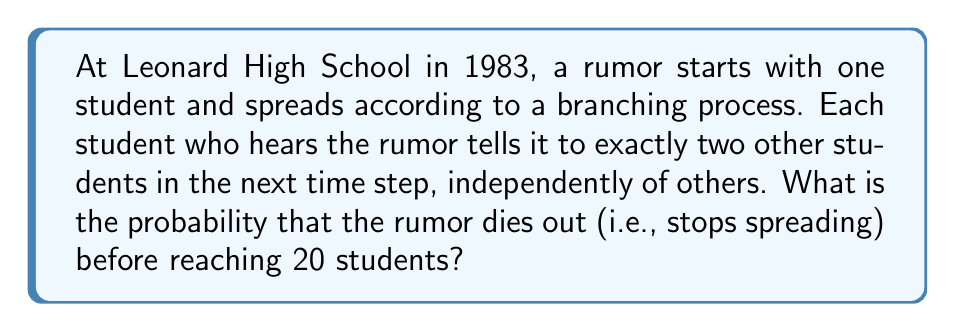Show me your answer to this math problem. Let's approach this step-by-step using branching process theory:

1) First, we need to identify the offspring distribution. In this case, each "parent" (student with the rumor) produces exactly 2 "offspring" (new students who hear the rumor). So the offspring distribution is deterministic with mean $\mu = 2$.

2) In a branching process, the probability of extinction, $q$, satisfies the equation:
   $q = G(q)$
   where $G(s)$ is the probability generating function (PGF) of the offspring distribution.

3) For our deterministic case with exactly 2 offspring, the PGF is:
   $G(s) = s^2$

4) So, we need to solve:
   $q = q^2$

5) This equation has two solutions: $q = 0$ or $q = 1$

6) Since $\mu = 2 > 1$, we know that the process is supercritical, meaning the probability of extinction is the smaller of these two solutions. Therefore, $q = 0$.

7) This means that the probability of the rumor dying out eventually is 0.

8) However, the question asks about the probability of the rumor dying out before reaching 20 students. Let's calculate this:

   - The process starts with 1 student
   - After 1 step, there are 3 students (1 + 2)
   - After 2 steps, there are 7 students (1 + 2 + 4)
   - After 3 steps, there are 15 students (1 + 2 + 4 + 8)
   - After 4 steps, there are 31 students (1 + 2 + 4 + 8 + 16)

9) We see that the rumor will definitely reach 20 students by the 4th step, unless it dies out before then.

10) The only way for the rumor to die out before reaching 20 students is if it dies out immediately after the first student (probability 0).

Therefore, the probability that the rumor dies out before reaching 20 students is 0.
Answer: 0 